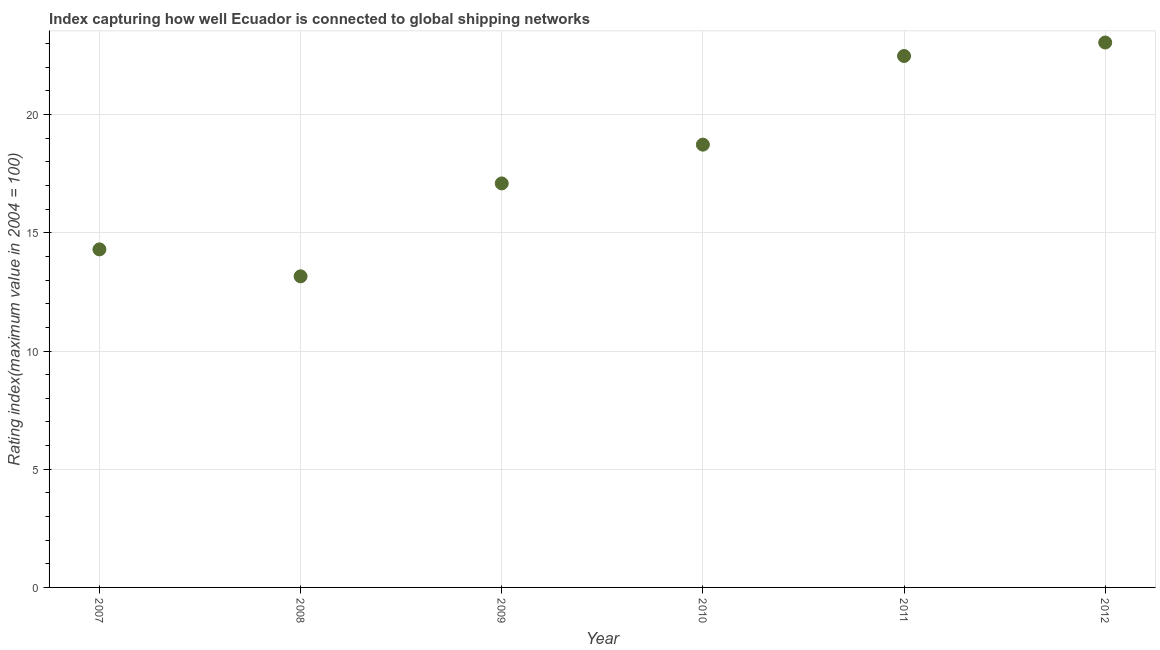What is the liner shipping connectivity index in 2012?
Provide a succinct answer. 23.05. Across all years, what is the maximum liner shipping connectivity index?
Your response must be concise. 23.05. Across all years, what is the minimum liner shipping connectivity index?
Provide a succinct answer. 13.16. In which year was the liner shipping connectivity index minimum?
Your answer should be very brief. 2008. What is the sum of the liner shipping connectivity index?
Provide a succinct answer. 108.81. What is the difference between the liner shipping connectivity index in 2008 and 2011?
Offer a terse response. -9.32. What is the average liner shipping connectivity index per year?
Offer a very short reply. 18.14. What is the median liner shipping connectivity index?
Offer a terse response. 17.91. Do a majority of the years between 2007 and 2012 (inclusive) have liner shipping connectivity index greater than 16 ?
Give a very brief answer. Yes. What is the ratio of the liner shipping connectivity index in 2007 to that in 2010?
Make the answer very short. 0.76. Is the difference between the liner shipping connectivity index in 2007 and 2011 greater than the difference between any two years?
Give a very brief answer. No. What is the difference between the highest and the second highest liner shipping connectivity index?
Your answer should be very brief. 0.57. What is the difference between the highest and the lowest liner shipping connectivity index?
Provide a succinct answer. 9.89. In how many years, is the liner shipping connectivity index greater than the average liner shipping connectivity index taken over all years?
Keep it short and to the point. 3. Does the liner shipping connectivity index monotonically increase over the years?
Your answer should be very brief. No. Are the values on the major ticks of Y-axis written in scientific E-notation?
Provide a succinct answer. No. Does the graph contain any zero values?
Your response must be concise. No. Does the graph contain grids?
Offer a terse response. Yes. What is the title of the graph?
Give a very brief answer. Index capturing how well Ecuador is connected to global shipping networks. What is the label or title of the X-axis?
Provide a short and direct response. Year. What is the label or title of the Y-axis?
Your answer should be very brief. Rating index(maximum value in 2004 = 100). What is the Rating index(maximum value in 2004 = 100) in 2007?
Provide a short and direct response. 14.3. What is the Rating index(maximum value in 2004 = 100) in 2008?
Make the answer very short. 13.16. What is the Rating index(maximum value in 2004 = 100) in 2009?
Your answer should be compact. 17.09. What is the Rating index(maximum value in 2004 = 100) in 2010?
Offer a very short reply. 18.73. What is the Rating index(maximum value in 2004 = 100) in 2011?
Offer a very short reply. 22.48. What is the Rating index(maximum value in 2004 = 100) in 2012?
Make the answer very short. 23.05. What is the difference between the Rating index(maximum value in 2004 = 100) in 2007 and 2008?
Your answer should be compact. 1.14. What is the difference between the Rating index(maximum value in 2004 = 100) in 2007 and 2009?
Offer a terse response. -2.79. What is the difference between the Rating index(maximum value in 2004 = 100) in 2007 and 2010?
Keep it short and to the point. -4.43. What is the difference between the Rating index(maximum value in 2004 = 100) in 2007 and 2011?
Your answer should be very brief. -8.18. What is the difference between the Rating index(maximum value in 2004 = 100) in 2007 and 2012?
Ensure brevity in your answer.  -8.75. What is the difference between the Rating index(maximum value in 2004 = 100) in 2008 and 2009?
Offer a very short reply. -3.93. What is the difference between the Rating index(maximum value in 2004 = 100) in 2008 and 2010?
Offer a very short reply. -5.57. What is the difference between the Rating index(maximum value in 2004 = 100) in 2008 and 2011?
Your answer should be compact. -9.32. What is the difference between the Rating index(maximum value in 2004 = 100) in 2008 and 2012?
Make the answer very short. -9.89. What is the difference between the Rating index(maximum value in 2004 = 100) in 2009 and 2010?
Make the answer very short. -1.64. What is the difference between the Rating index(maximum value in 2004 = 100) in 2009 and 2011?
Ensure brevity in your answer.  -5.39. What is the difference between the Rating index(maximum value in 2004 = 100) in 2009 and 2012?
Your answer should be very brief. -5.96. What is the difference between the Rating index(maximum value in 2004 = 100) in 2010 and 2011?
Give a very brief answer. -3.75. What is the difference between the Rating index(maximum value in 2004 = 100) in 2010 and 2012?
Keep it short and to the point. -4.32. What is the difference between the Rating index(maximum value in 2004 = 100) in 2011 and 2012?
Your answer should be very brief. -0.57. What is the ratio of the Rating index(maximum value in 2004 = 100) in 2007 to that in 2008?
Offer a terse response. 1.09. What is the ratio of the Rating index(maximum value in 2004 = 100) in 2007 to that in 2009?
Offer a very short reply. 0.84. What is the ratio of the Rating index(maximum value in 2004 = 100) in 2007 to that in 2010?
Provide a succinct answer. 0.76. What is the ratio of the Rating index(maximum value in 2004 = 100) in 2007 to that in 2011?
Provide a succinct answer. 0.64. What is the ratio of the Rating index(maximum value in 2004 = 100) in 2007 to that in 2012?
Your answer should be very brief. 0.62. What is the ratio of the Rating index(maximum value in 2004 = 100) in 2008 to that in 2009?
Provide a short and direct response. 0.77. What is the ratio of the Rating index(maximum value in 2004 = 100) in 2008 to that in 2010?
Your answer should be very brief. 0.7. What is the ratio of the Rating index(maximum value in 2004 = 100) in 2008 to that in 2011?
Make the answer very short. 0.58. What is the ratio of the Rating index(maximum value in 2004 = 100) in 2008 to that in 2012?
Your response must be concise. 0.57. What is the ratio of the Rating index(maximum value in 2004 = 100) in 2009 to that in 2010?
Your answer should be compact. 0.91. What is the ratio of the Rating index(maximum value in 2004 = 100) in 2009 to that in 2011?
Your response must be concise. 0.76. What is the ratio of the Rating index(maximum value in 2004 = 100) in 2009 to that in 2012?
Your response must be concise. 0.74. What is the ratio of the Rating index(maximum value in 2004 = 100) in 2010 to that in 2011?
Ensure brevity in your answer.  0.83. What is the ratio of the Rating index(maximum value in 2004 = 100) in 2010 to that in 2012?
Give a very brief answer. 0.81. 